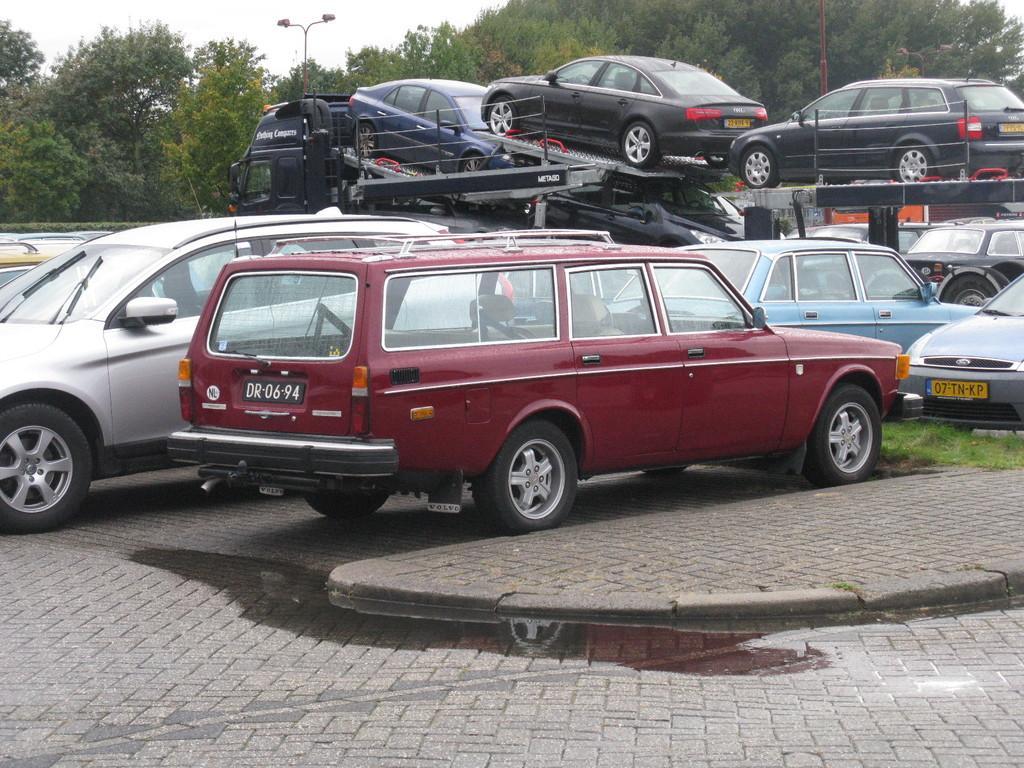Describe this image in one or two sentences. Here we can see cars. This is grass. In the background we can see trees, poles, and sky. 